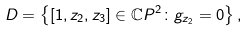Convert formula to latex. <formula><loc_0><loc_0><loc_500><loc_500>D = \left \{ [ 1 , z _ { 2 } , z _ { 3 } ] \in \mathbb { C } P ^ { 2 } \colon g _ { z _ { 2 } } = 0 \right \} ,</formula> 